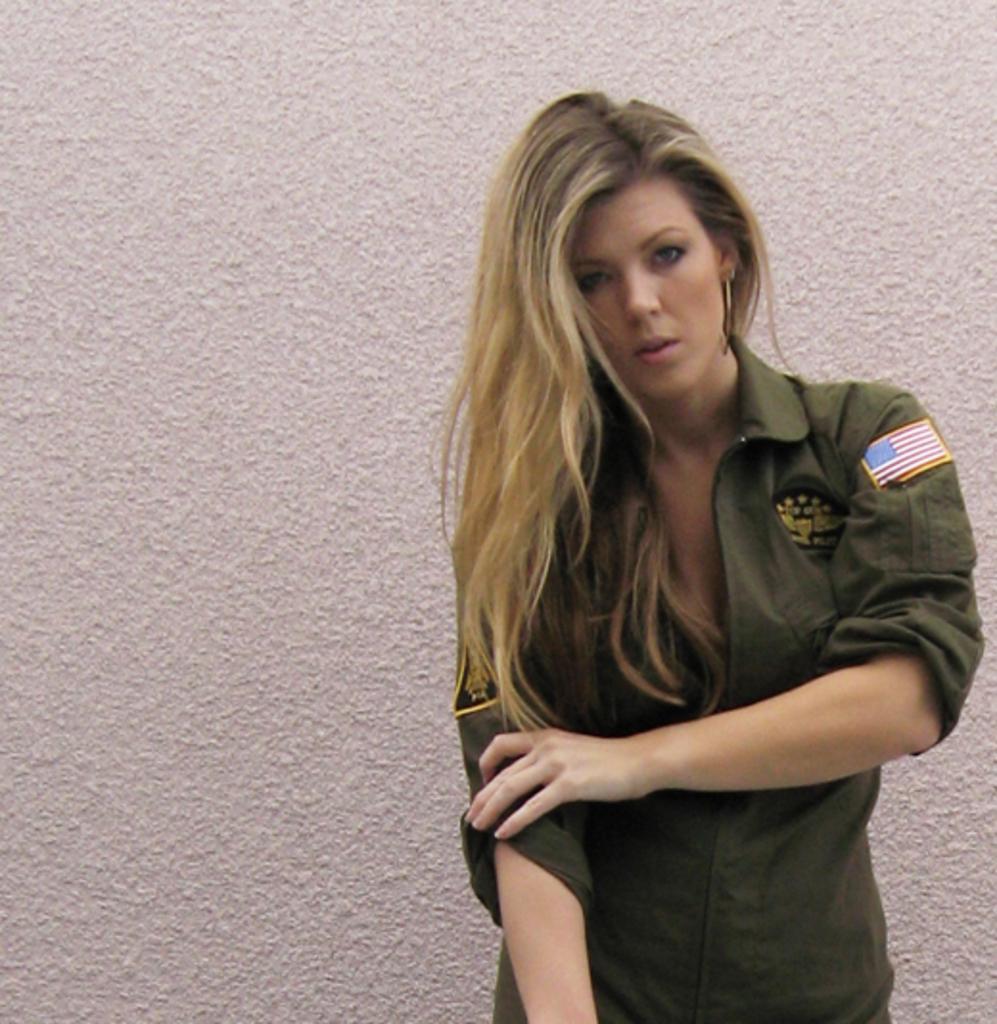How would you summarize this image in a sentence or two? In this image we can see there is a person standing and at the back there is a wall. 